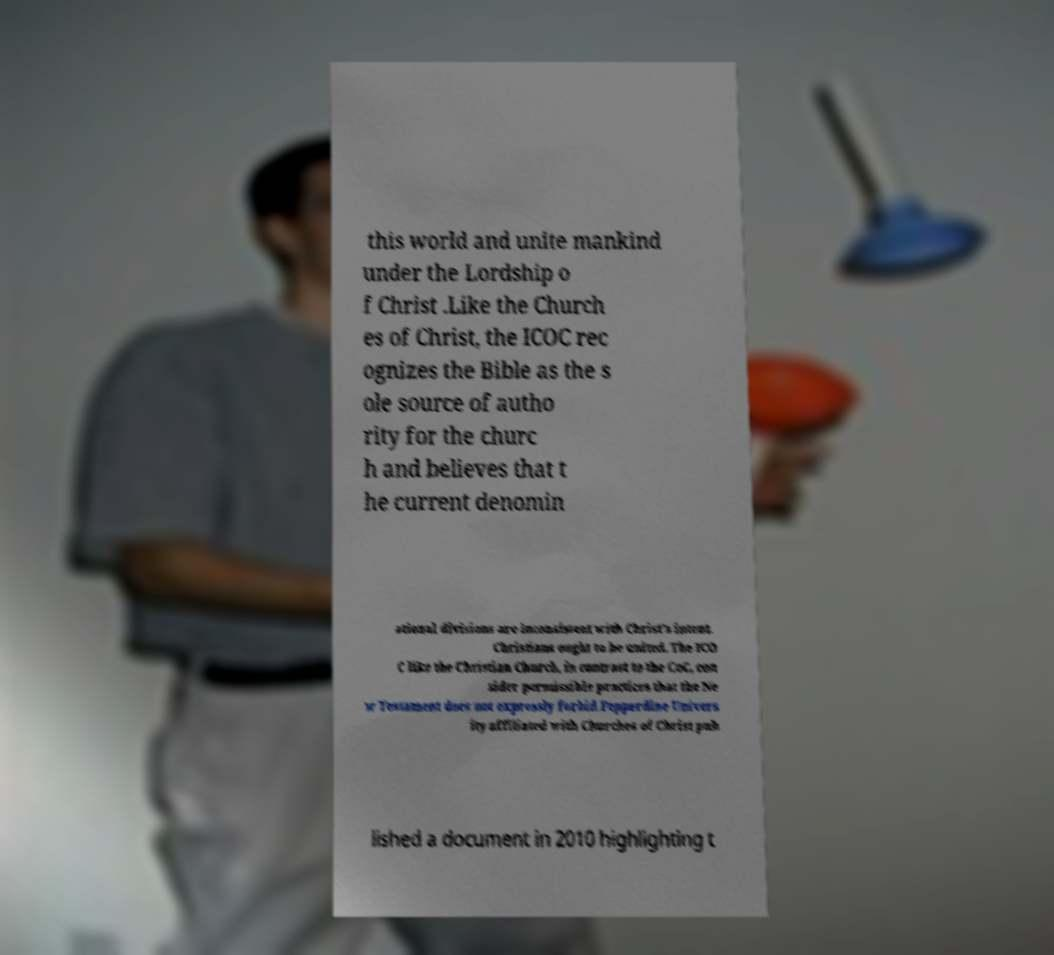I need the written content from this picture converted into text. Can you do that? this world and unite mankind under the Lordship o f Christ .Like the Church es of Christ, the ICOC rec ognizes the Bible as the s ole source of autho rity for the churc h and believes that t he current denomin ational divisions are inconsistent with Christ's intent. Christians ought to be united. The ICO C like the Christian Church, in contrast to the CoC, con sider permissible practices that the Ne w Testament does not expressly forbid.Pepperdine Univers ity affiliated with Churches of Christ pub lished a document in 2010 highlighting t 